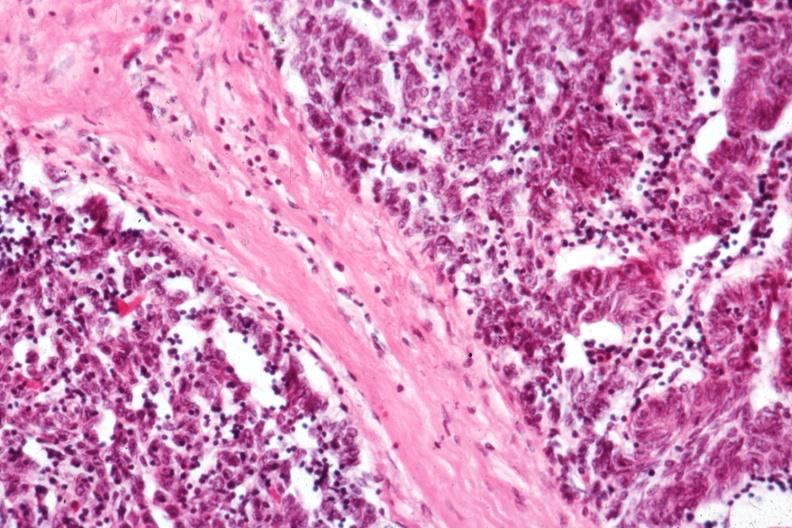what is present?
Answer the question using a single word or phrase. Hematologic 